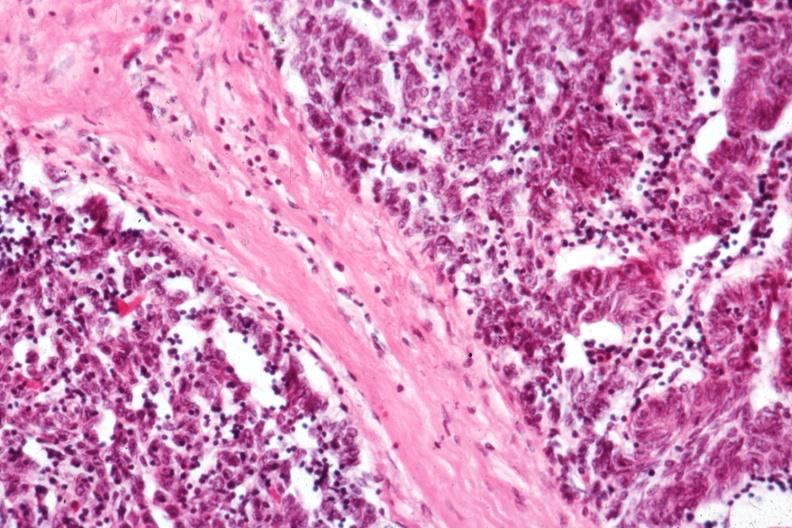what is present?
Answer the question using a single word or phrase. Hematologic 